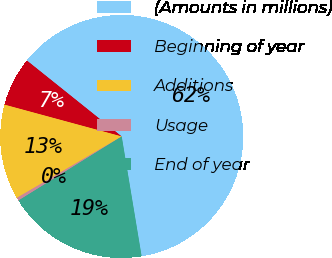<chart> <loc_0><loc_0><loc_500><loc_500><pie_chart><fcel>(Amounts in millions)<fcel>Beginning of year<fcel>Additions<fcel>Usage<fcel>End of year<nl><fcel>61.63%<fcel>6.53%<fcel>12.65%<fcel>0.41%<fcel>18.78%<nl></chart> 